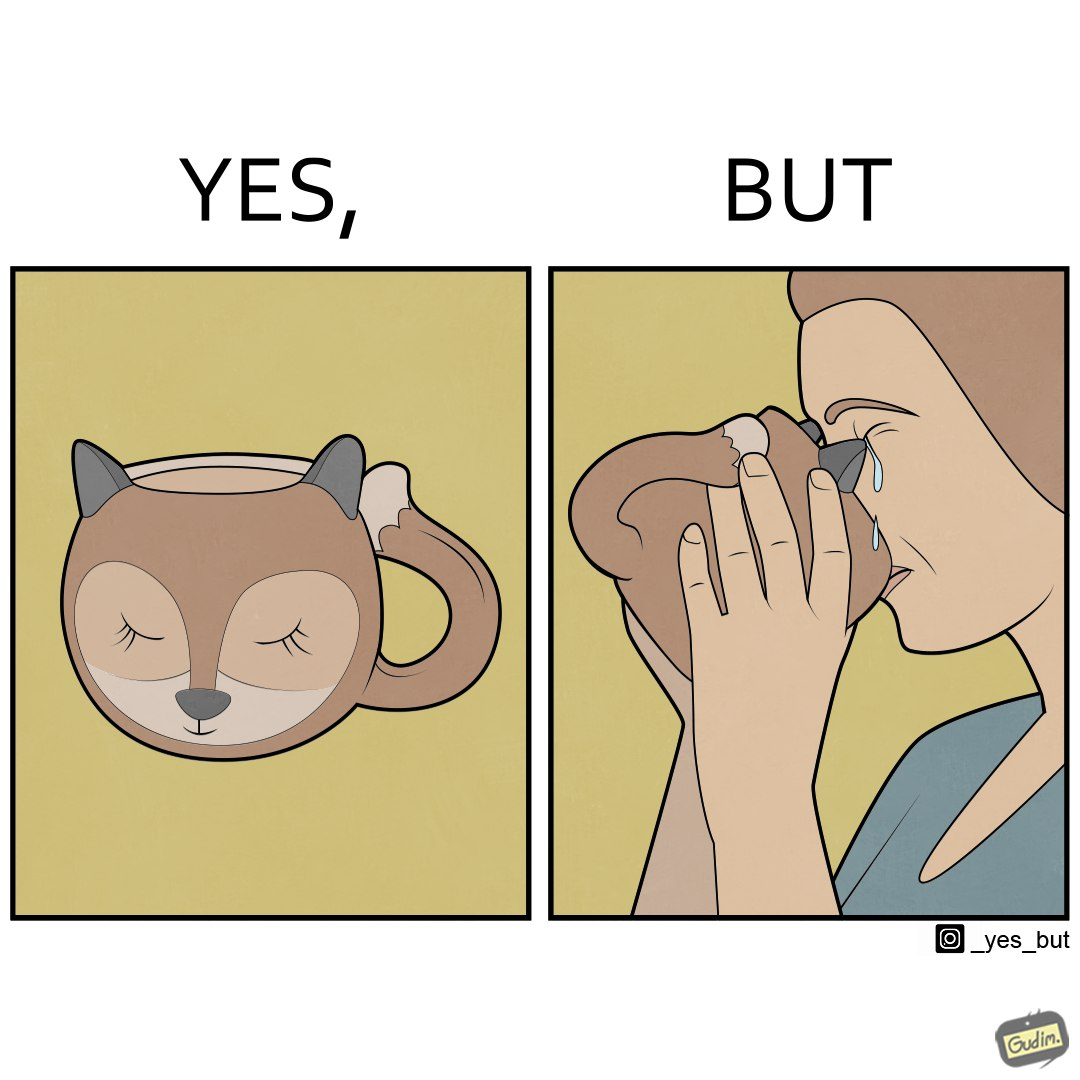Describe the contrast between the left and right parts of this image. In the left part of the image: A mug that looks like a cat's face and has cat's facial features like ears In the right part of the image: a woman drinking from a mug and crying because something on the mug is poking in her face 